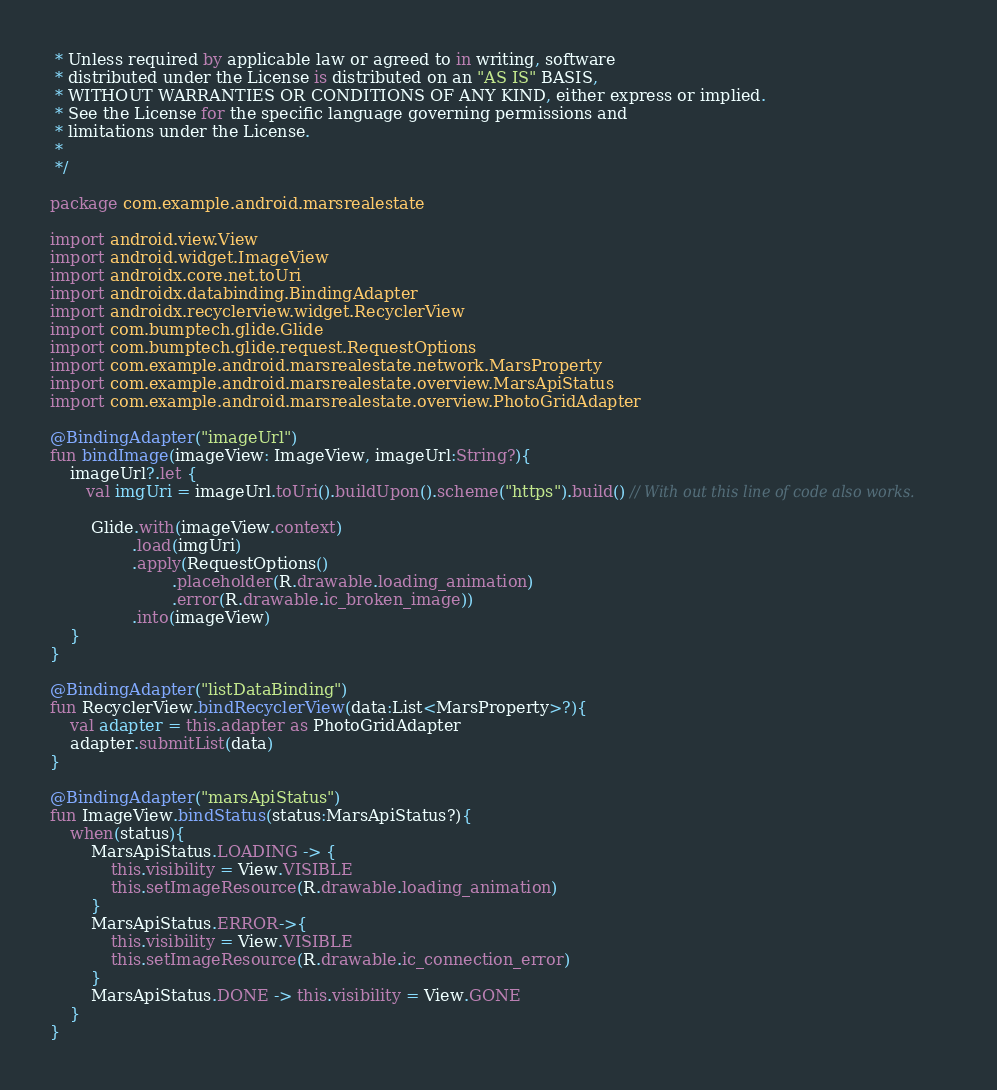<code> <loc_0><loc_0><loc_500><loc_500><_Kotlin_> * Unless required by applicable law or agreed to in writing, software
 * distributed under the License is distributed on an "AS IS" BASIS,
 * WITHOUT WARRANTIES OR CONDITIONS OF ANY KIND, either express or implied.
 * See the License for the specific language governing permissions and
 * limitations under the License.
 *
 */

package com.example.android.marsrealestate

import android.view.View
import android.widget.ImageView
import androidx.core.net.toUri
import androidx.databinding.BindingAdapter
import androidx.recyclerview.widget.RecyclerView
import com.bumptech.glide.Glide
import com.bumptech.glide.request.RequestOptions
import com.example.android.marsrealestate.network.MarsProperty
import com.example.android.marsrealestate.overview.MarsApiStatus
import com.example.android.marsrealestate.overview.PhotoGridAdapter

@BindingAdapter("imageUrl")
fun bindImage(imageView: ImageView, imageUrl:String?){
    imageUrl?.let {
       val imgUri = imageUrl.toUri().buildUpon().scheme("https").build() // With out this line of code also works.

        Glide.with(imageView.context)
                .load(imgUri)
                .apply(RequestOptions()
                        .placeholder(R.drawable.loading_animation)
                        .error(R.drawable.ic_broken_image))
                .into(imageView)
    }
}

@BindingAdapter("listDataBinding")
fun RecyclerView.bindRecyclerView(data:List<MarsProperty>?){
    val adapter = this.adapter as PhotoGridAdapter
    adapter.submitList(data)
}

@BindingAdapter("marsApiStatus")
fun ImageView.bindStatus(status:MarsApiStatus?){
    when(status){
        MarsApiStatus.LOADING -> {
            this.visibility = View.VISIBLE
            this.setImageResource(R.drawable.loading_animation)
        }
        MarsApiStatus.ERROR->{
            this.visibility = View.VISIBLE
            this.setImageResource(R.drawable.ic_connection_error)
        }
        MarsApiStatus.DONE -> this.visibility = View.GONE
    }
}</code> 